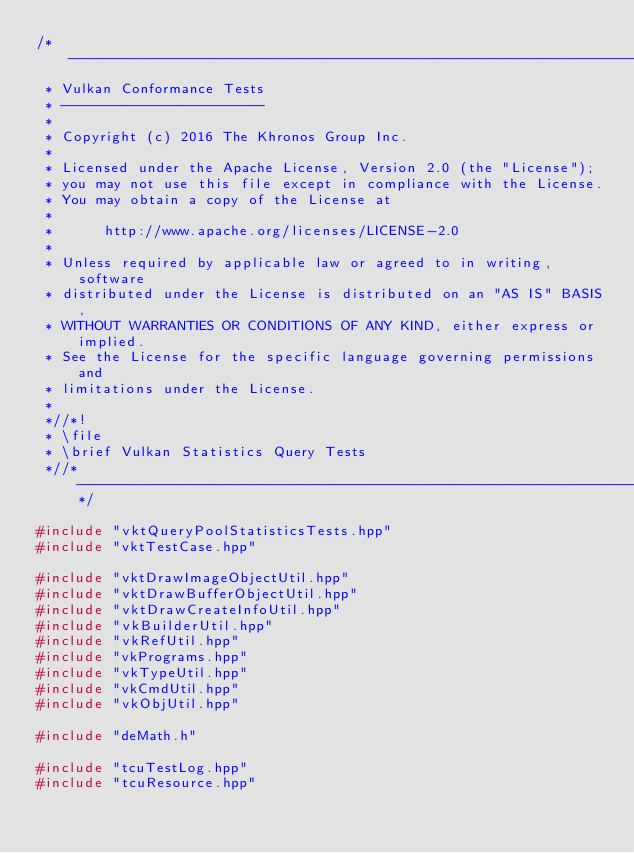<code> <loc_0><loc_0><loc_500><loc_500><_C++_>/*------------------------------------------------------------------------
 * Vulkan Conformance Tests
 * ------------------------
 *
 * Copyright (c) 2016 The Khronos Group Inc.
 *
 * Licensed under the Apache License, Version 2.0 (the "License");
 * you may not use this file except in compliance with the License.
 * You may obtain a copy of the License at
 *
 *      http://www.apache.org/licenses/LICENSE-2.0
 *
 * Unless required by applicable law or agreed to in writing, software
 * distributed under the License is distributed on an "AS IS" BASIS,
 * WITHOUT WARRANTIES OR CONDITIONS OF ANY KIND, either express or implied.
 * See the License for the specific language governing permissions and
 * limitations under the License.
 *
 *//*!
 * \file
 * \brief Vulkan Statistics Query Tests
 *//*--------------------------------------------------------------------*/

#include "vktQueryPoolStatisticsTests.hpp"
#include "vktTestCase.hpp"

#include "vktDrawImageObjectUtil.hpp"
#include "vktDrawBufferObjectUtil.hpp"
#include "vktDrawCreateInfoUtil.hpp"
#include "vkBuilderUtil.hpp"
#include "vkRefUtil.hpp"
#include "vkPrograms.hpp"
#include "vkTypeUtil.hpp"
#include "vkCmdUtil.hpp"
#include "vkObjUtil.hpp"

#include "deMath.h"

#include "tcuTestLog.hpp"
#include "tcuResource.hpp"</code> 